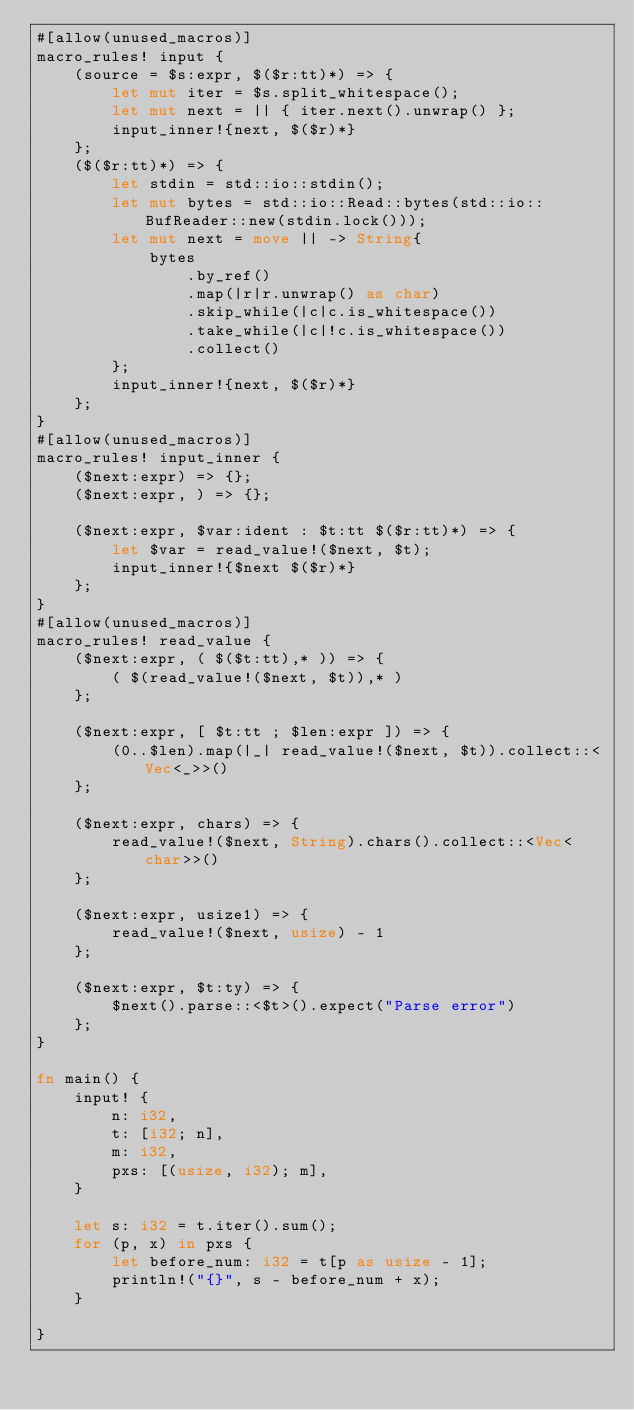<code> <loc_0><loc_0><loc_500><loc_500><_Rust_>#[allow(unused_macros)]
macro_rules! input {
    (source = $s:expr, $($r:tt)*) => {
        let mut iter = $s.split_whitespace();
        let mut next = || { iter.next().unwrap() };
        input_inner!{next, $($r)*}
    };
    ($($r:tt)*) => {
        let stdin = std::io::stdin();
        let mut bytes = std::io::Read::bytes(std::io::BufReader::new(stdin.lock()));
        let mut next = move || -> String{
            bytes
                .by_ref()
                .map(|r|r.unwrap() as char)
                .skip_while(|c|c.is_whitespace())
                .take_while(|c|!c.is_whitespace())
                .collect()
        };
        input_inner!{next, $($r)*}
    };
}
#[allow(unused_macros)]
macro_rules! input_inner {
    ($next:expr) => {};
    ($next:expr, ) => {};

    ($next:expr, $var:ident : $t:tt $($r:tt)*) => {
        let $var = read_value!($next, $t);
        input_inner!{$next $($r)*}
    };
}
#[allow(unused_macros)]
macro_rules! read_value {
    ($next:expr, ( $($t:tt),* )) => {
        ( $(read_value!($next, $t)),* )
    };

    ($next:expr, [ $t:tt ; $len:expr ]) => {
        (0..$len).map(|_| read_value!($next, $t)).collect::<Vec<_>>()
    };

    ($next:expr, chars) => {
        read_value!($next, String).chars().collect::<Vec<char>>()
    };

    ($next:expr, usize1) => {
        read_value!($next, usize) - 1
    };

    ($next:expr, $t:ty) => {
        $next().parse::<$t>().expect("Parse error")
    };
}

fn main() {
    input! {
        n: i32,
        t: [i32; n],
        m: i32,
        pxs: [(usize, i32); m],
    }

    let s: i32 = t.iter().sum();
    for (p, x) in pxs {
        let before_num: i32 = t[p as usize - 1];
        println!("{}", s - before_num + x);
    }

} 
</code> 